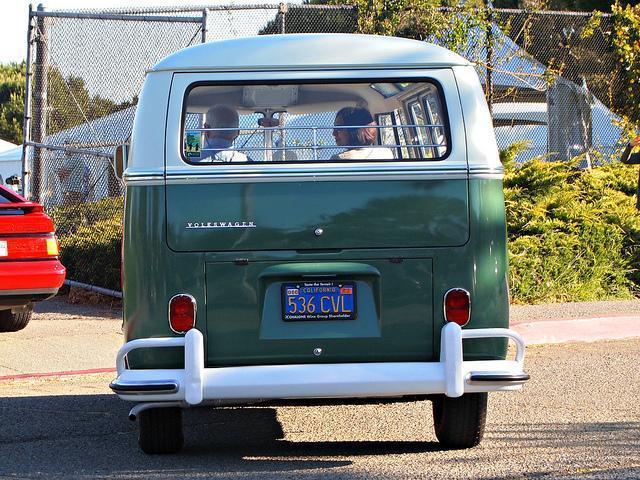How many people in the van?
Give a very brief answer. 2. How many baby elephants are there?
Give a very brief answer. 0. 